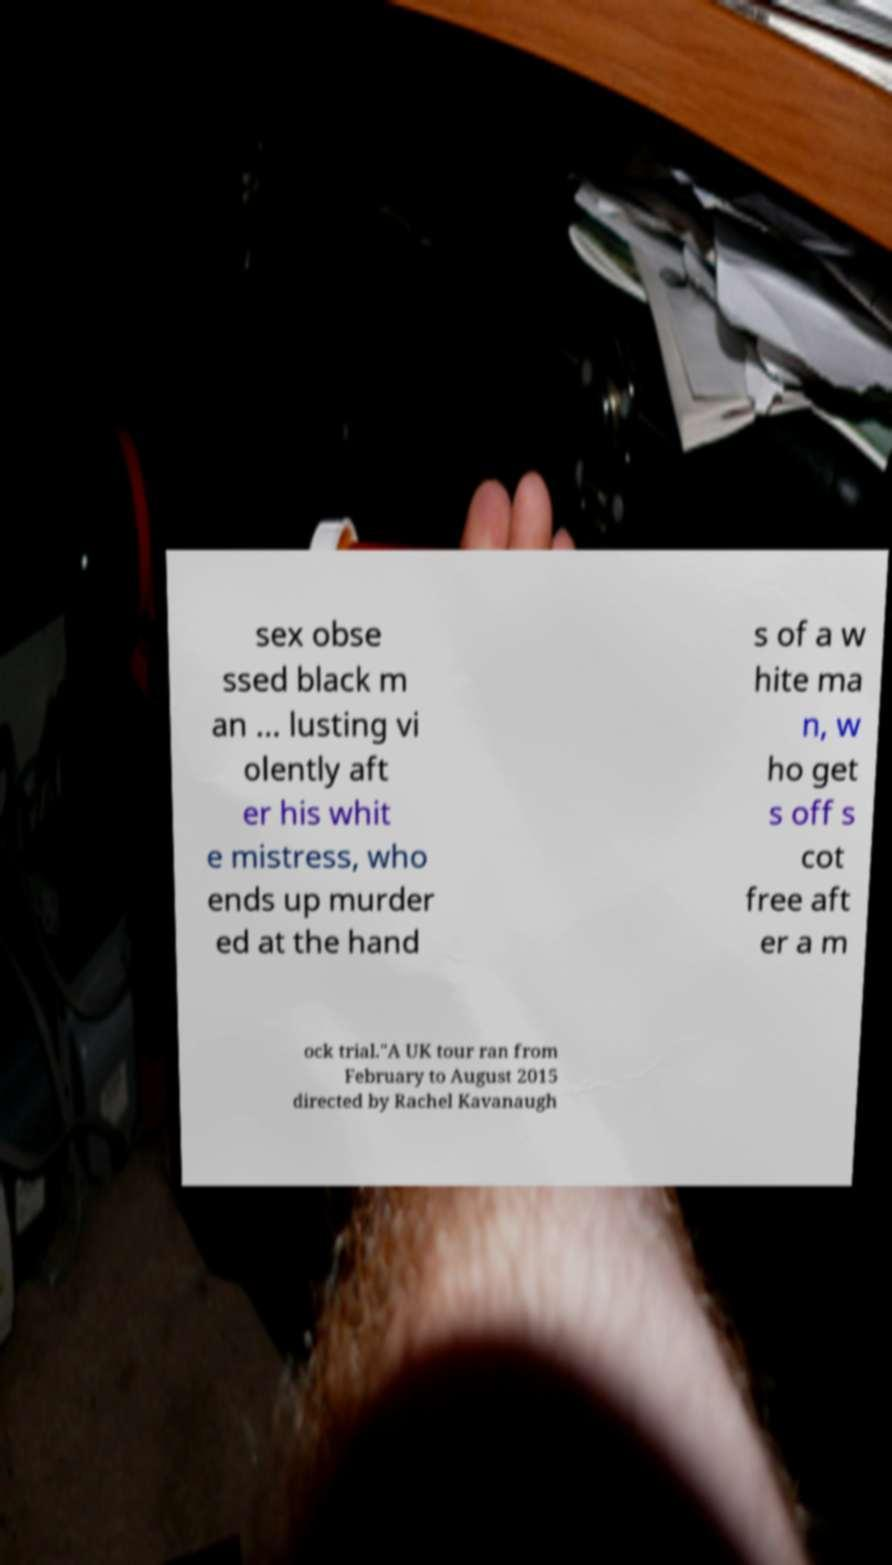Could you extract and type out the text from this image? sex obse ssed black m an ... lusting vi olently aft er his whit e mistress, who ends up murder ed at the hand s of a w hite ma n, w ho get s off s cot free aft er a m ock trial."A UK tour ran from February to August 2015 directed by Rachel Kavanaugh 